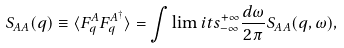Convert formula to latex. <formula><loc_0><loc_0><loc_500><loc_500>S _ { A A } ( q ) \equiv \langle F _ { q } ^ { A } F _ { q } ^ { A ^ { \dagger } } \rangle = \int \lim i t s _ { - \infty } ^ { + \infty } \frac { d \omega } { 2 \pi } S _ { A A } ( q , \omega ) ,</formula> 